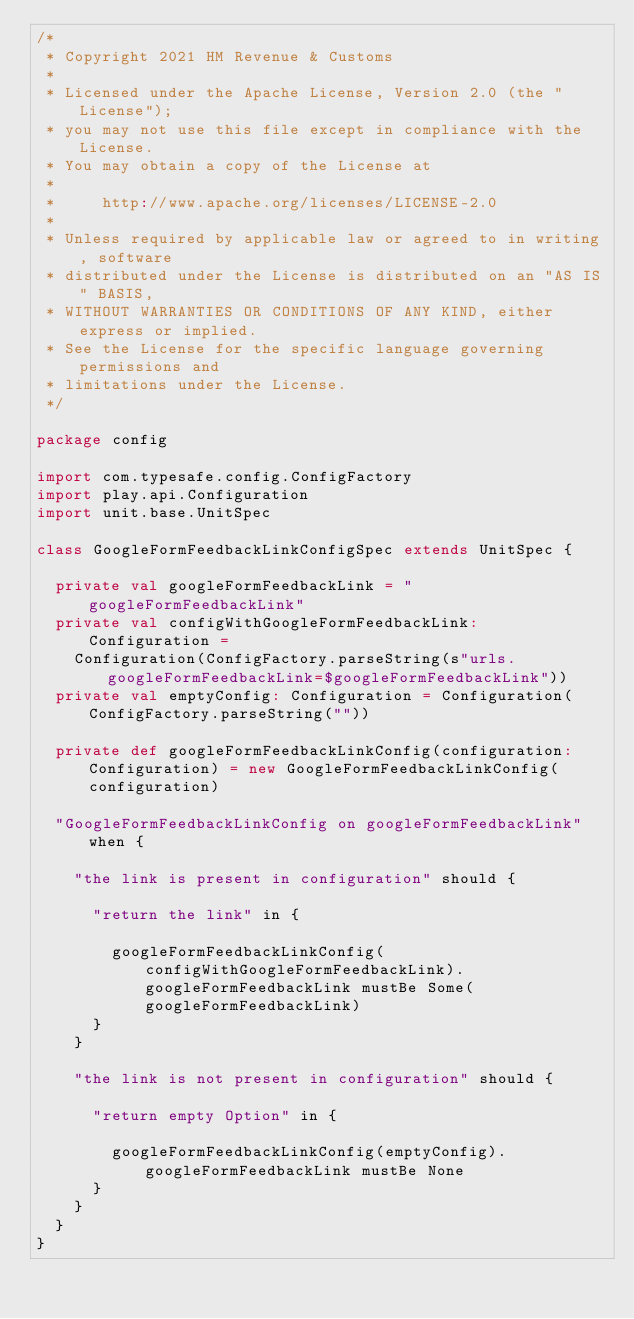Convert code to text. <code><loc_0><loc_0><loc_500><loc_500><_Scala_>/*
 * Copyright 2021 HM Revenue & Customs
 *
 * Licensed under the Apache License, Version 2.0 (the "License");
 * you may not use this file except in compliance with the License.
 * You may obtain a copy of the License at
 *
 *     http://www.apache.org/licenses/LICENSE-2.0
 *
 * Unless required by applicable law or agreed to in writing, software
 * distributed under the License is distributed on an "AS IS" BASIS,
 * WITHOUT WARRANTIES OR CONDITIONS OF ANY KIND, either express or implied.
 * See the License for the specific language governing permissions and
 * limitations under the License.
 */

package config

import com.typesafe.config.ConfigFactory
import play.api.Configuration
import unit.base.UnitSpec

class GoogleFormFeedbackLinkConfigSpec extends UnitSpec {

  private val googleFormFeedbackLink = "googleFormFeedbackLink"
  private val configWithGoogleFormFeedbackLink: Configuration =
    Configuration(ConfigFactory.parseString(s"urls.googleFormFeedbackLink=$googleFormFeedbackLink"))
  private val emptyConfig: Configuration = Configuration(ConfigFactory.parseString(""))

  private def googleFormFeedbackLinkConfig(configuration: Configuration) = new GoogleFormFeedbackLinkConfig(configuration)

  "GoogleFormFeedbackLinkConfig on googleFormFeedbackLink" when {

    "the link is present in configuration" should {

      "return the link" in {

        googleFormFeedbackLinkConfig(configWithGoogleFormFeedbackLink).googleFormFeedbackLink mustBe Some(googleFormFeedbackLink)
      }
    }

    "the link is not present in configuration" should {

      "return empty Option" in {

        googleFormFeedbackLinkConfig(emptyConfig).googleFormFeedbackLink mustBe None
      }
    }
  }
}
</code> 